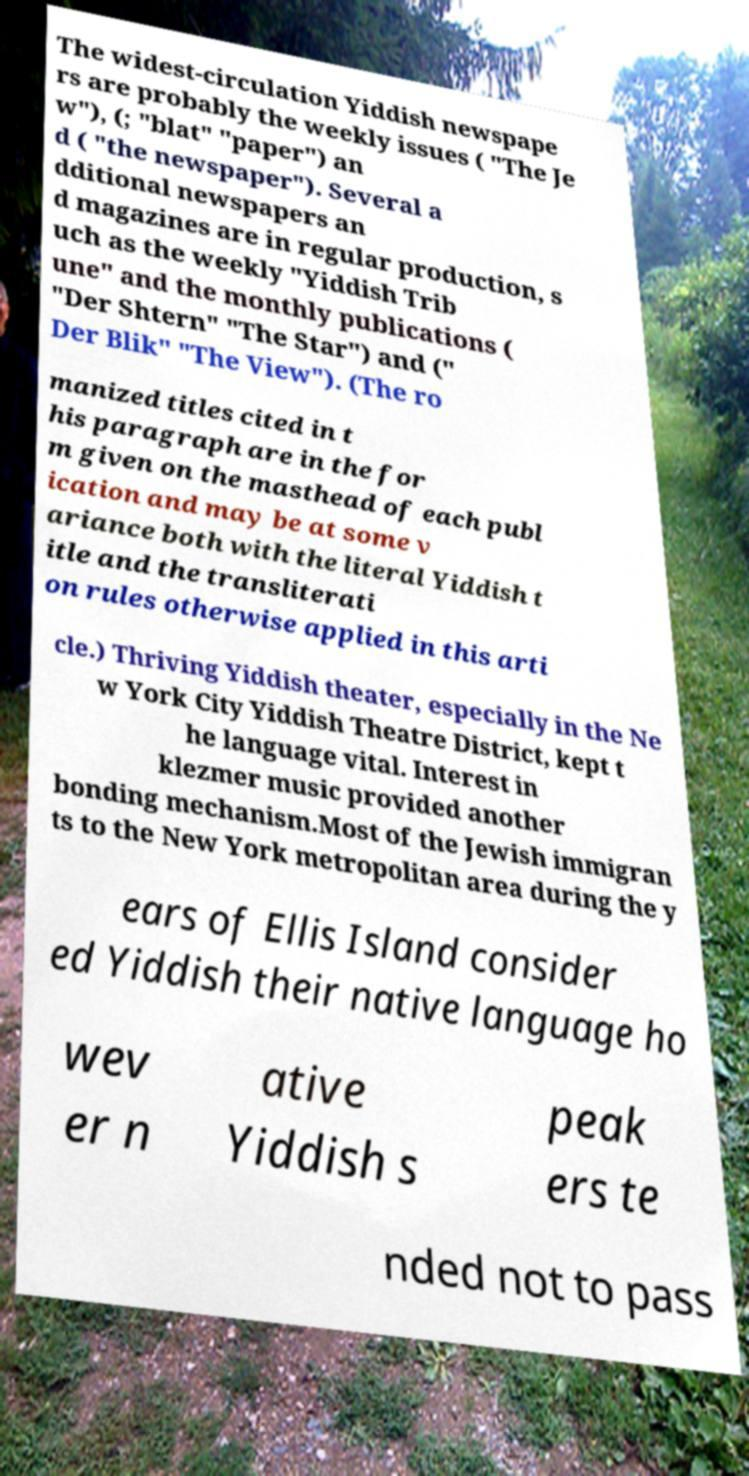For documentation purposes, I need the text within this image transcribed. Could you provide that? The widest-circulation Yiddish newspape rs are probably the weekly issues ( "The Je w"), (; "blat" "paper") an d ( "the newspaper"). Several a dditional newspapers an d magazines are in regular production, s uch as the weekly "Yiddish Trib une" and the monthly publications ( "Der Shtern" "The Star") and (" Der Blik" "The View"). (The ro manized titles cited in t his paragraph are in the for m given on the masthead of each publ ication and may be at some v ariance both with the literal Yiddish t itle and the transliterati on rules otherwise applied in this arti cle.) Thriving Yiddish theater, especially in the Ne w York City Yiddish Theatre District, kept t he language vital. Interest in klezmer music provided another bonding mechanism.Most of the Jewish immigran ts to the New York metropolitan area during the y ears of Ellis Island consider ed Yiddish their native language ho wev er n ative Yiddish s peak ers te nded not to pass 